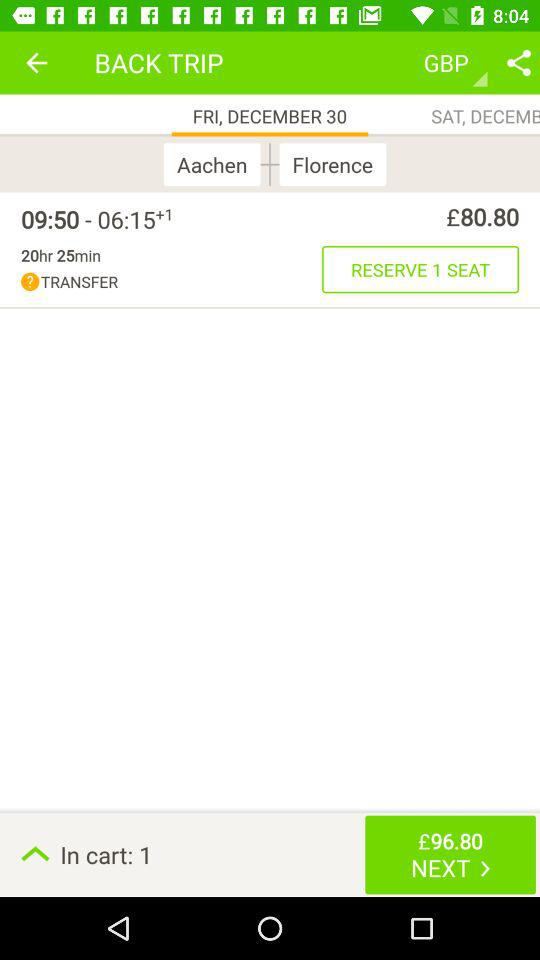How much is the time duration? The time duration is 20 hours 25 minutes. 